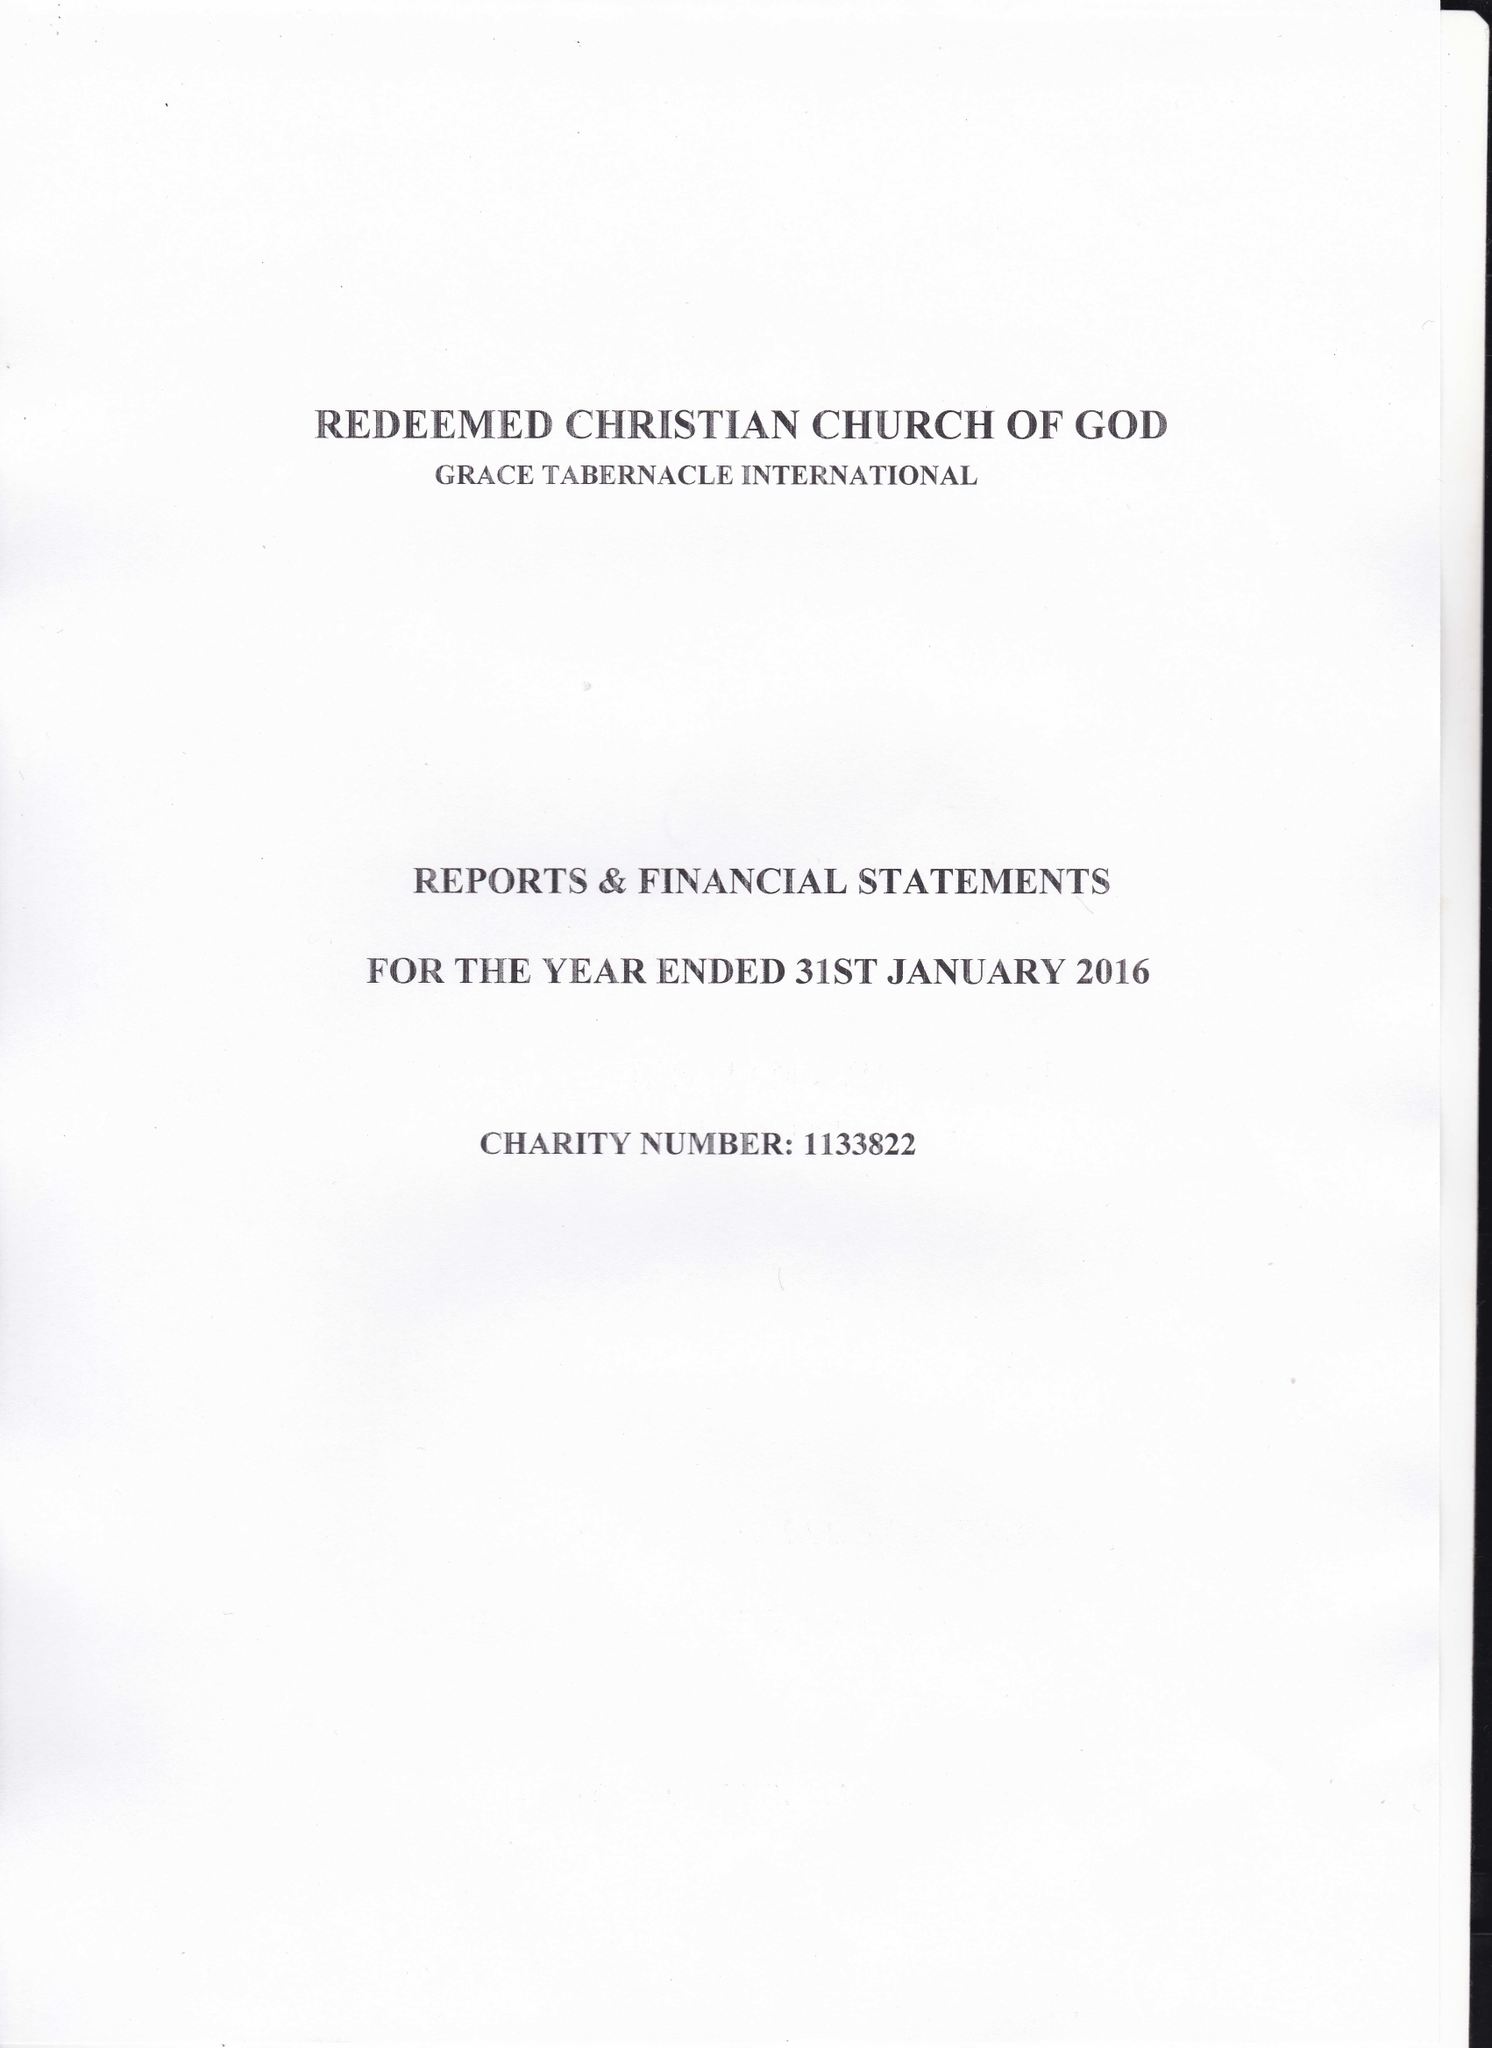What is the value for the report_date?
Answer the question using a single word or phrase. 2016-01-31 